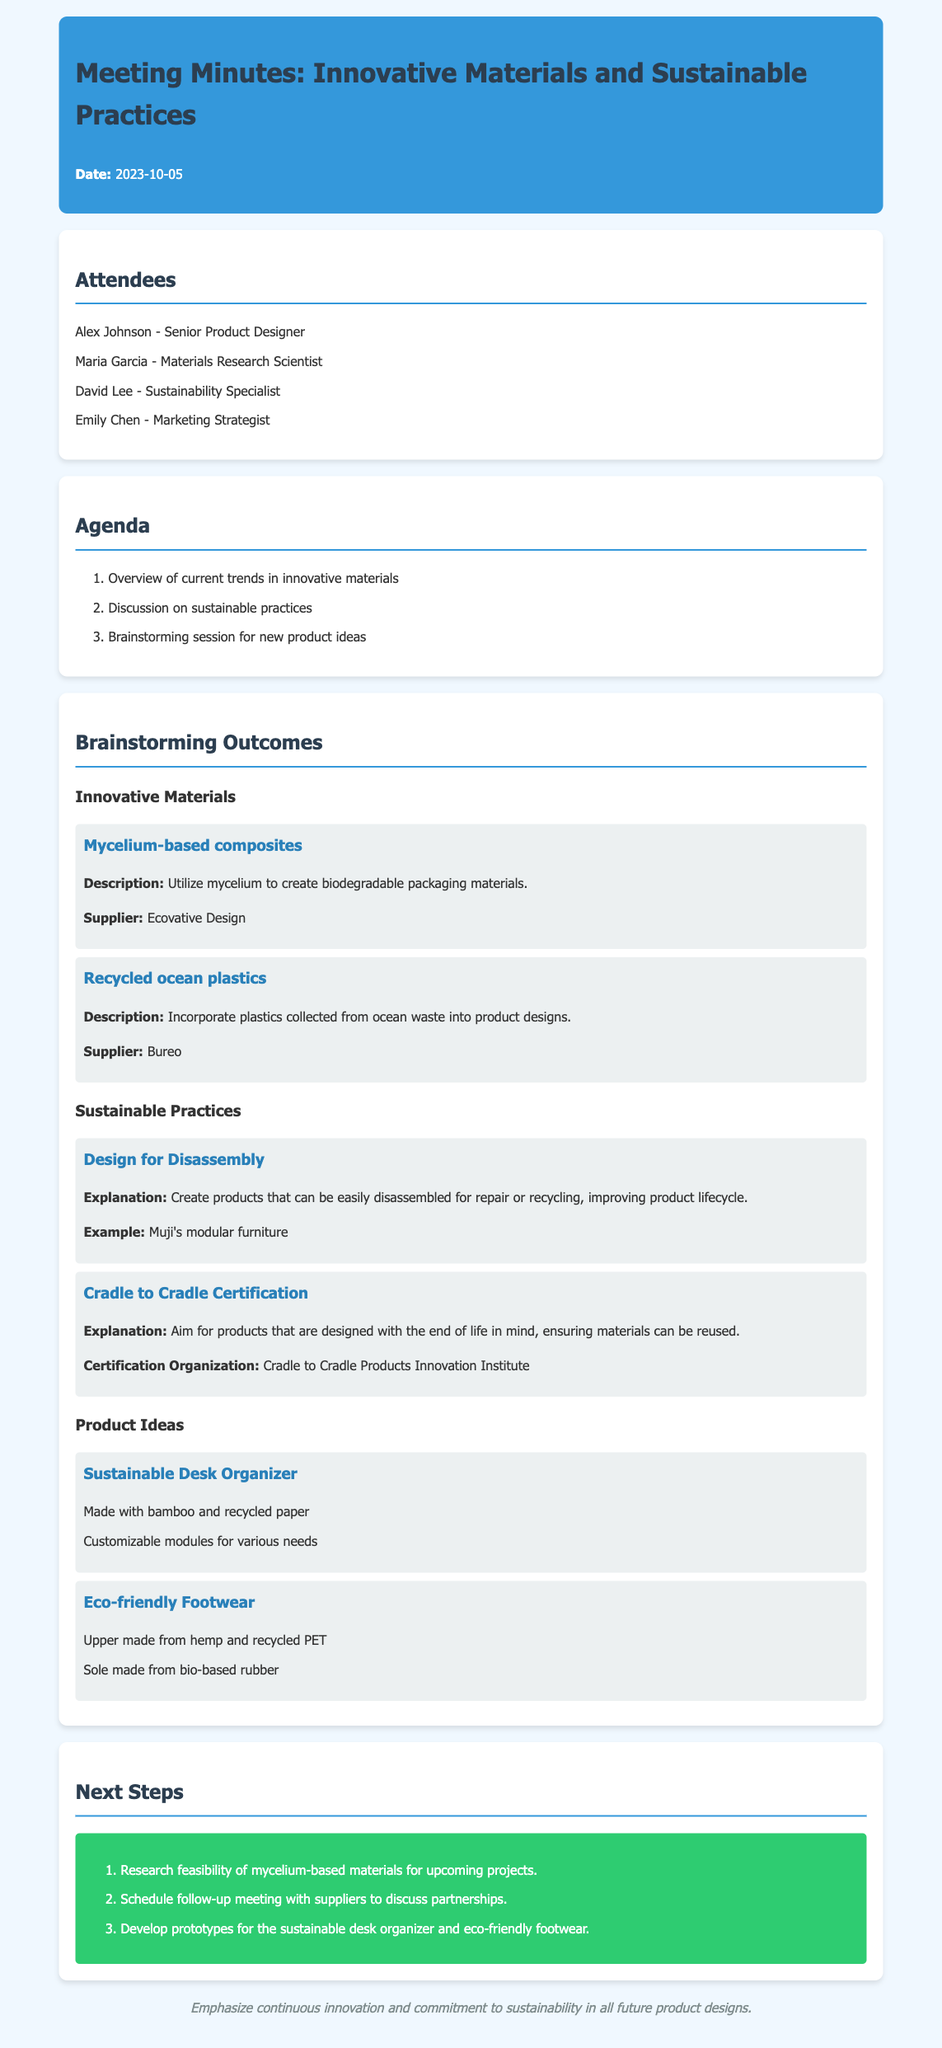what is the date of the meeting? The date of the meeting is mentioned at the top of the document.
Answer: 2023-10-05 who is the Sustainability Specialist? The document lists the attendees and their roles, including the Sustainability Specialist.
Answer: David Lee what innovative material uses mycelium? The outcomes section describes innovative materials, including one that utilizes mycelium for a specific purpose.
Answer: Mycelium-based composites what is the goal of Cradle to Cradle Certification? The description of the sustainable practice explains the main purpose of this certification.
Answer: Ensure materials can be reused what are the materials used in the Sustainable Desk Organizer? The product idea section lists specific materials used in this product design.
Answer: Bamboo and recycled paper which organization provides Cradle to Cradle Certification? The document mentions the name of the organization responsible for this certification.
Answer: Cradle to Cradle Products Innovation Institute how many product ideas were presented in the meeting? The document includes a list of product ideas under a specific section, which can be counted.
Answer: 2 what is one next step mentioned for the mycelium-based materials? The next steps section lists specific actions to be taken, one related to mycelium-based materials.
Answer: Research feasibility of mycelium-based materials for upcoming projects 